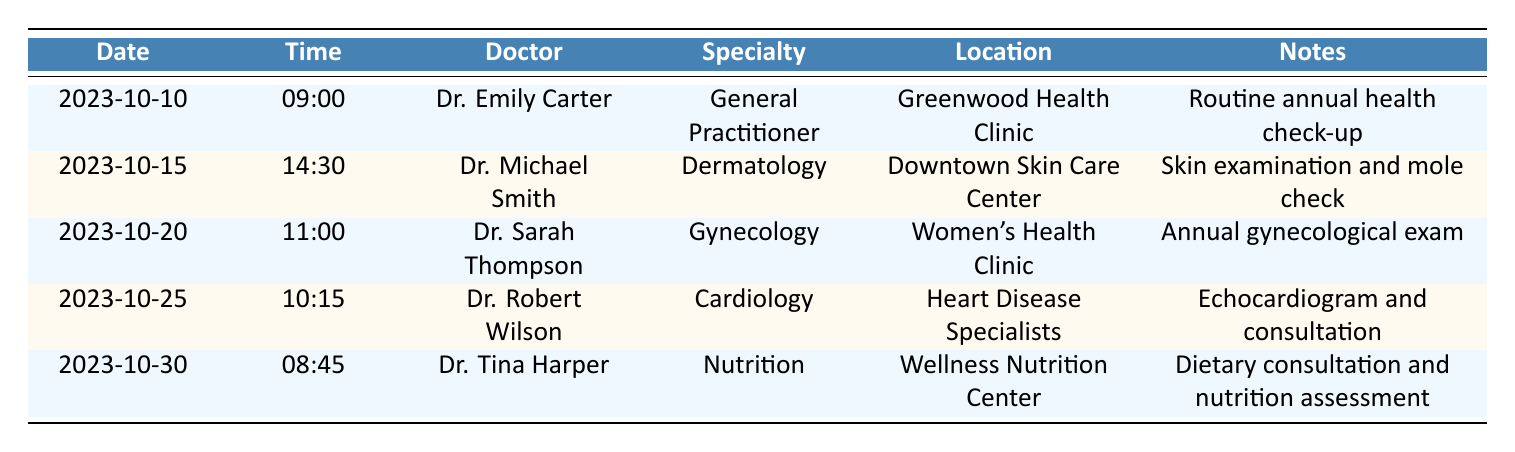What is the date of Miranda's next appointment? The next appointment listed for Miranda Johnson is on 2023-10-15.
Answer: 2023-10-15 Who is the doctor for Miranda's gynecological exam? The appointment for the gynecological exam is with Dr. Sarah Thompson.
Answer: Dr. Sarah Thompson How many appointments does Miranda have scheduled in October? There are a total of five appointments scheduled for Miranda in October.
Answer: 5 Is there an appointment scheduled on October 25th? Yes, there is an appointment on October 25th with Dr. Robert Wilson for an echocardiogram and consultation.
Answer: Yes On what date and time is Miranda's appointment with Dr. Michael Smith? The appointment with Dr. Michael Smith is on October 15th at 14:30.
Answer: October 15th at 14:30 What is the average time of Miranda's appointments? The appointment times are 09:00, 14:30, 11:00, 10:15, and 08:45. Converting these to minutes since midnight gives (540, 870, 660, 615, 525). The sum is 3170 minutes, divided by 5 appointments gives an average of 634 minutes, which is 10 hours and 34 minutes or 10:34.
Answer: 10:34 What specialty is represented by the appointment on October 30th? The appointment on October 30th is a Nutrition specialty with Dr. Tina Harper.
Answer: Nutrition Is there an appointment at the Women's Health Clinic? Yes, there is an appointment at the Women's Health Clinic for an annual gynecological exam with Dr. Sarah Thompson.
Answer: Yes How many of Miranda's appointments are with doctors specializing in general practice? Only one appointment is with a doctor specializing in general practice, which is with Dr. Emily Carter on October 10th.
Answer: 1 What time does Miranda's last appointment of the month start? The last appointment of the month on October 30th starts at 08:45.
Answer: 08:45 